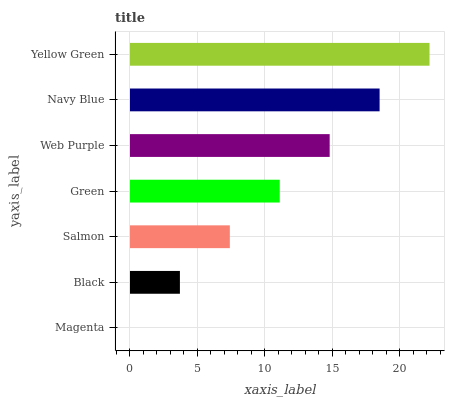Is Magenta the minimum?
Answer yes or no. Yes. Is Yellow Green the maximum?
Answer yes or no. Yes. Is Black the minimum?
Answer yes or no. No. Is Black the maximum?
Answer yes or no. No. Is Black greater than Magenta?
Answer yes or no. Yes. Is Magenta less than Black?
Answer yes or no. Yes. Is Magenta greater than Black?
Answer yes or no. No. Is Black less than Magenta?
Answer yes or no. No. Is Green the high median?
Answer yes or no. Yes. Is Green the low median?
Answer yes or no. Yes. Is Web Purple the high median?
Answer yes or no. No. Is Salmon the low median?
Answer yes or no. No. 